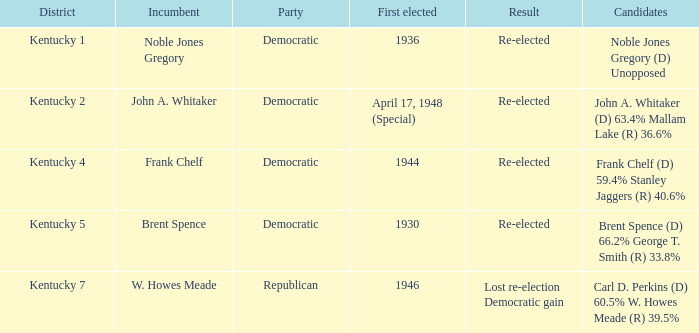What was the result of the election incumbent Brent Spence took place in? Re-elected. 